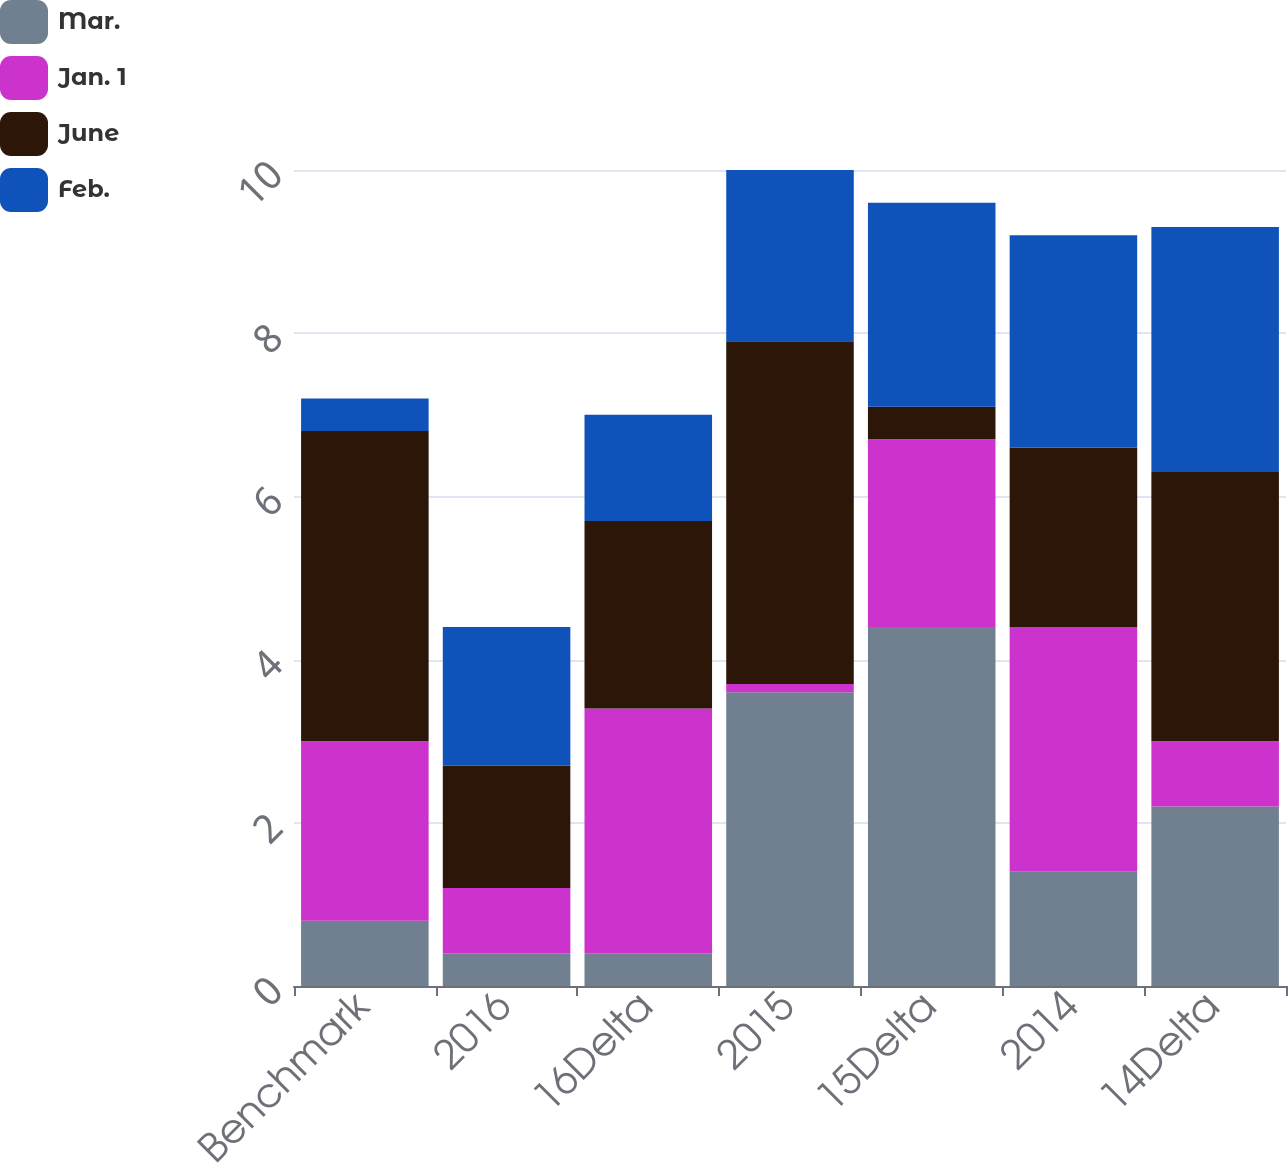Convert chart to OTSL. <chart><loc_0><loc_0><loc_500><loc_500><stacked_bar_chart><ecel><fcel>Benchmark<fcel>2016<fcel>16Delta<fcel>2015<fcel>15Delta<fcel>2014<fcel>14Delta<nl><fcel>Mar.<fcel>0.8<fcel>0.4<fcel>0.4<fcel>3.6<fcel>4.4<fcel>1.4<fcel>2.2<nl><fcel>Jan. 1<fcel>2.2<fcel>0.8<fcel>3<fcel>0.1<fcel>2.3<fcel>3<fcel>0.8<nl><fcel>June<fcel>3.8<fcel>1.5<fcel>2.3<fcel>4.2<fcel>0.4<fcel>2.2<fcel>3.3<nl><fcel>Feb.<fcel>0.4<fcel>1.7<fcel>1.3<fcel>2.1<fcel>2.5<fcel>2.6<fcel>3<nl></chart> 